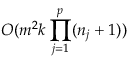Convert formula to latex. <formula><loc_0><loc_0><loc_500><loc_500>O ( m ^ { 2 } k \prod _ { j = 1 } ^ { p } ( n _ { j } + 1 ) )</formula> 